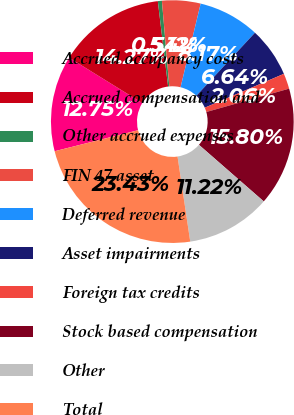<chart> <loc_0><loc_0><loc_500><loc_500><pie_chart><fcel>Accrued occupancy costs<fcel>Accrued compensation and<fcel>Other accrued expenses<fcel>FIN 47 asset<fcel>Deferred revenue<fcel>Asset impairments<fcel>Foreign tax credits<fcel>Stock based compensation<fcel>Other<fcel>Total<nl><fcel>12.75%<fcel>14.27%<fcel>0.54%<fcel>5.12%<fcel>8.17%<fcel>6.64%<fcel>2.06%<fcel>15.8%<fcel>11.22%<fcel>23.43%<nl></chart> 